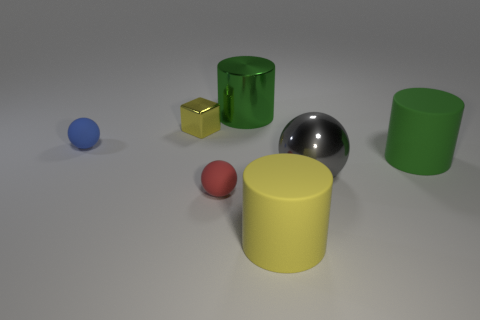What is the size of the metallic thing that is the same shape as the large yellow rubber object?
Keep it short and to the point. Large. Are there the same number of yellow cylinders that are on the right side of the big yellow cylinder and green metallic objects?
Your answer should be compact. No. Is the shape of the metallic thing in front of the cube the same as  the tiny blue object?
Provide a succinct answer. Yes. What shape is the large green metal thing?
Offer a very short reply. Cylinder. What material is the yellow object right of the yellow thing that is on the left side of the small matte ball that is in front of the large gray object made of?
Give a very brief answer. Rubber. What material is the other object that is the same color as the tiny metal thing?
Provide a succinct answer. Rubber. How many objects are large yellow matte cylinders or red balls?
Ensure brevity in your answer.  2. Are the yellow thing that is to the left of the metallic cylinder and the blue sphere made of the same material?
Your response must be concise. No. What number of things are either tiny balls that are left of the red rubber ball or small blue cylinders?
Your answer should be very brief. 1. What is the color of the tiny thing that is the same material as the big gray thing?
Offer a very short reply. Yellow. 